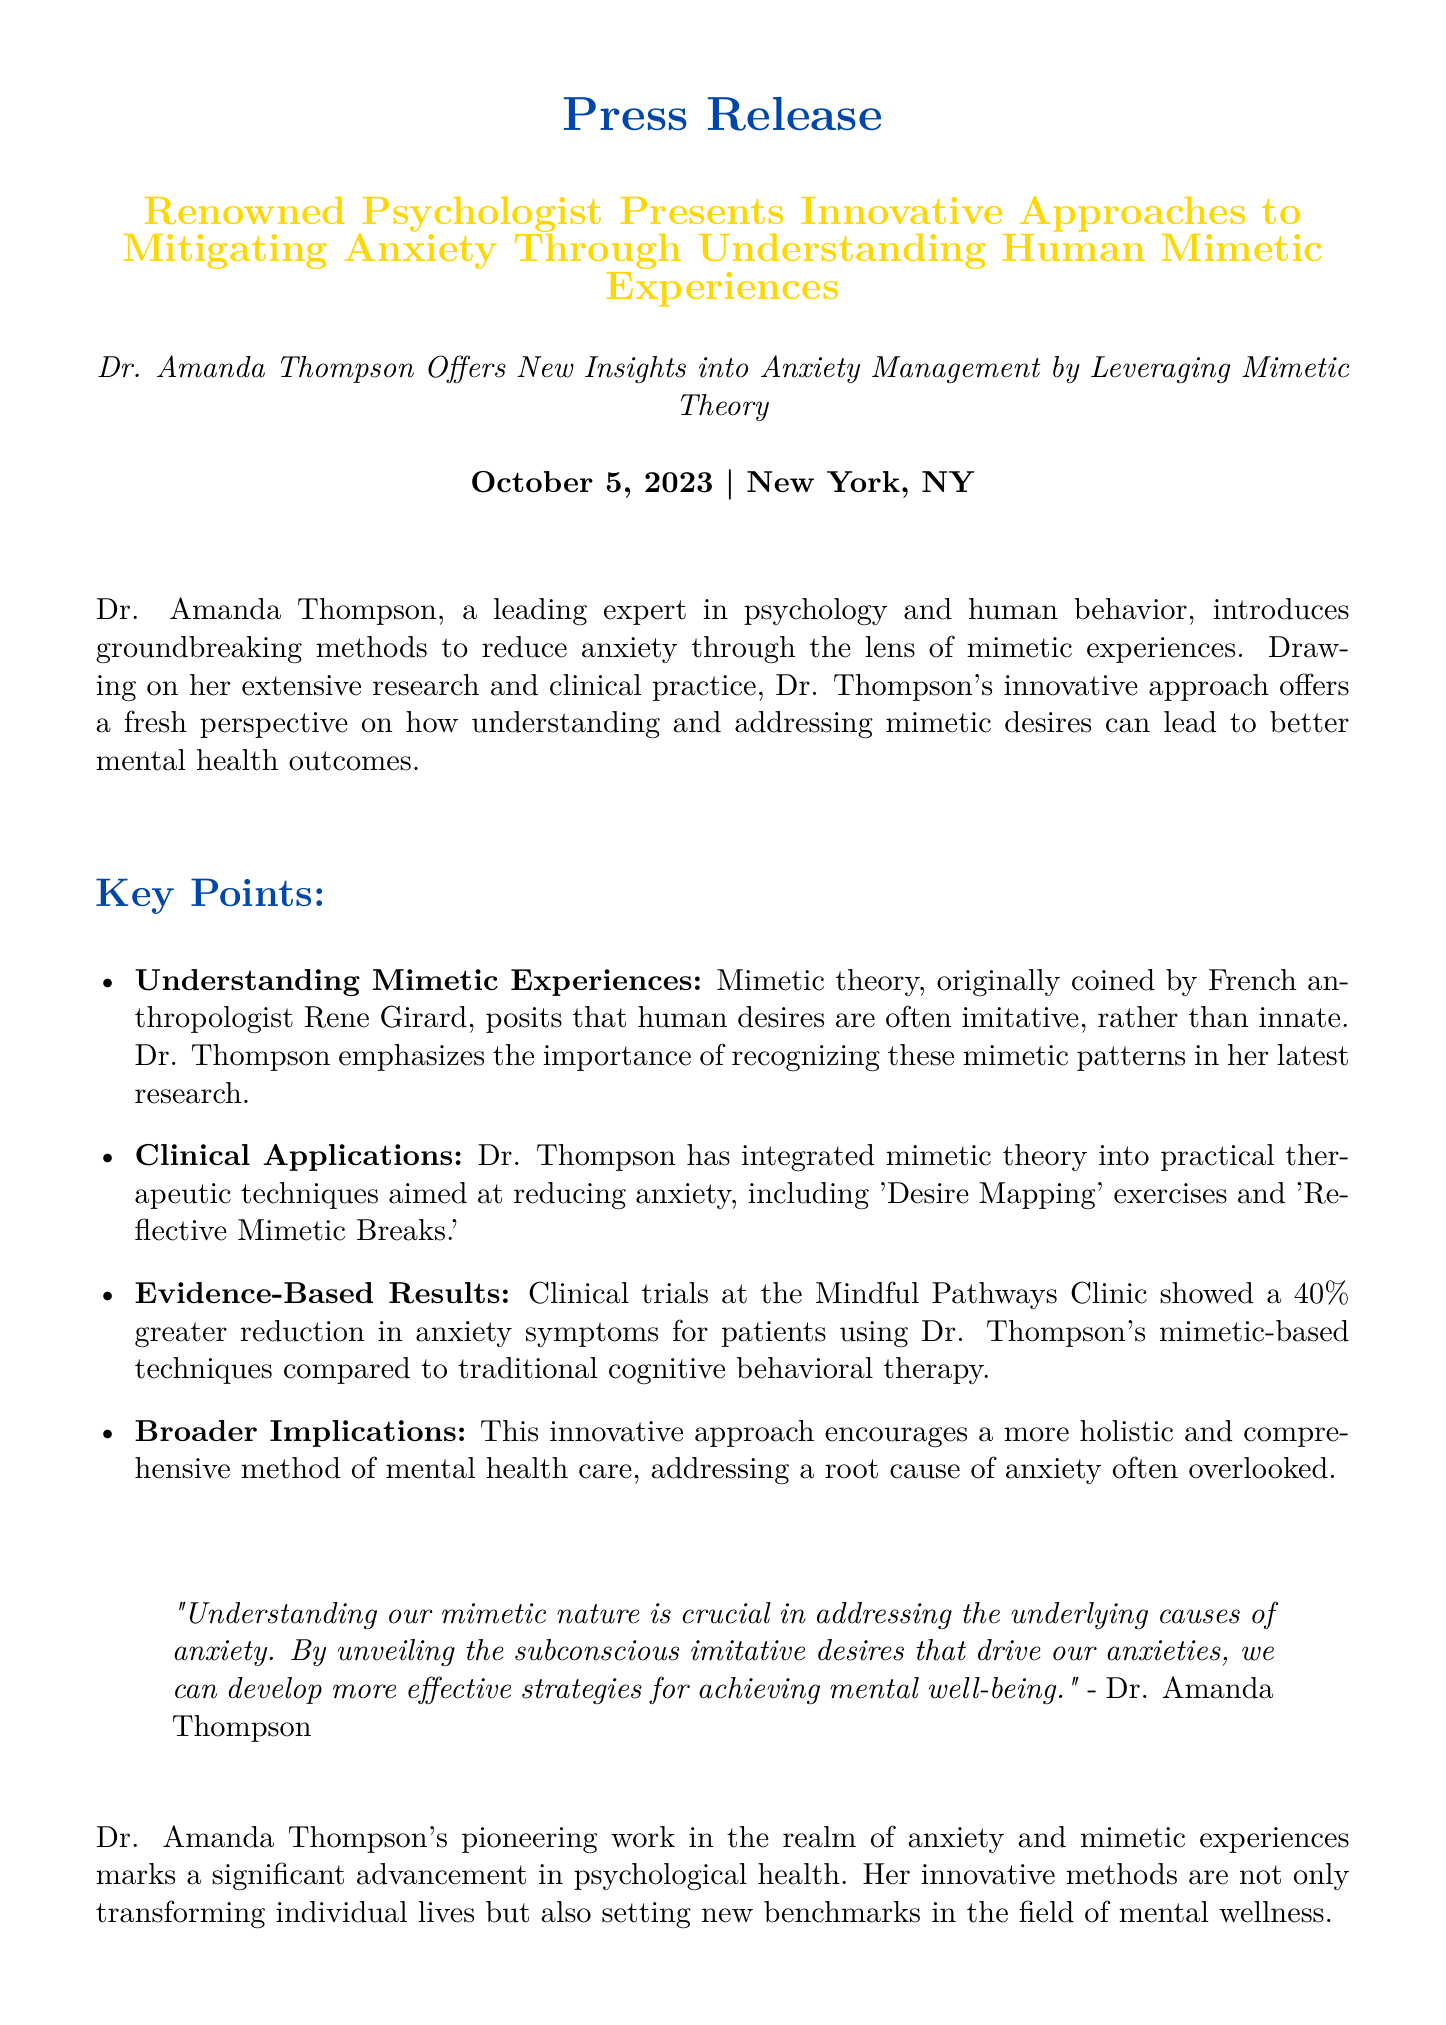What is the name of the psychologist mentioned? The document introduces Dr. Amanda Thompson as the psychologist presenting innovative approaches.
Answer: Dr. Amanda Thompson What is the main topic of the press release? The press release discusses innovative approaches to mitigating anxiety through an understanding of human mimetic experiences.
Answer: Mitigating anxiety through understanding human mimetic experiences What percentage reduction in anxiety symptoms was shown in clinical trials? The document states that there was a 40% greater reduction in anxiety symptoms for patients using the new techniques.
Answer: 40% What type of therapy did Dr. Thompson's methods show better results than? The document mentions that Dr. Thompson's mimetic-based techniques were compared to traditional cognitive behavioral therapy.
Answer: Traditional cognitive behavioral therapy What is the name of the clinic associated with Dr. Amanda Thompson? The Mindful Pathways Clinic is identified as the clinic where Dr. Thompson works and conducts her clinical trials.
Answer: Mindful Pathways Clinic What is one specific technique mentioned in Dr. Thompson's approach? The press release lists 'Desire Mapping' exercises as one of the practical therapeutic techniques integrated into her approach.
Answer: Desire Mapping What date was the press release issued? The document clearly indicates that the press release was issued on October 5, 2023.
Answer: October 5, 2023 What key concept does Dr. Thompson emphasize in her research? The press release highlights the importance of recognizing mimetic patterns as a key concept in Dr. Thompson's research.
Answer: Recognizing mimetic patterns Who originally coined the term "mimetic theory"? The document attributes the term "mimetic theory" to French anthropologist Rene Girard.
Answer: Rene Girard 